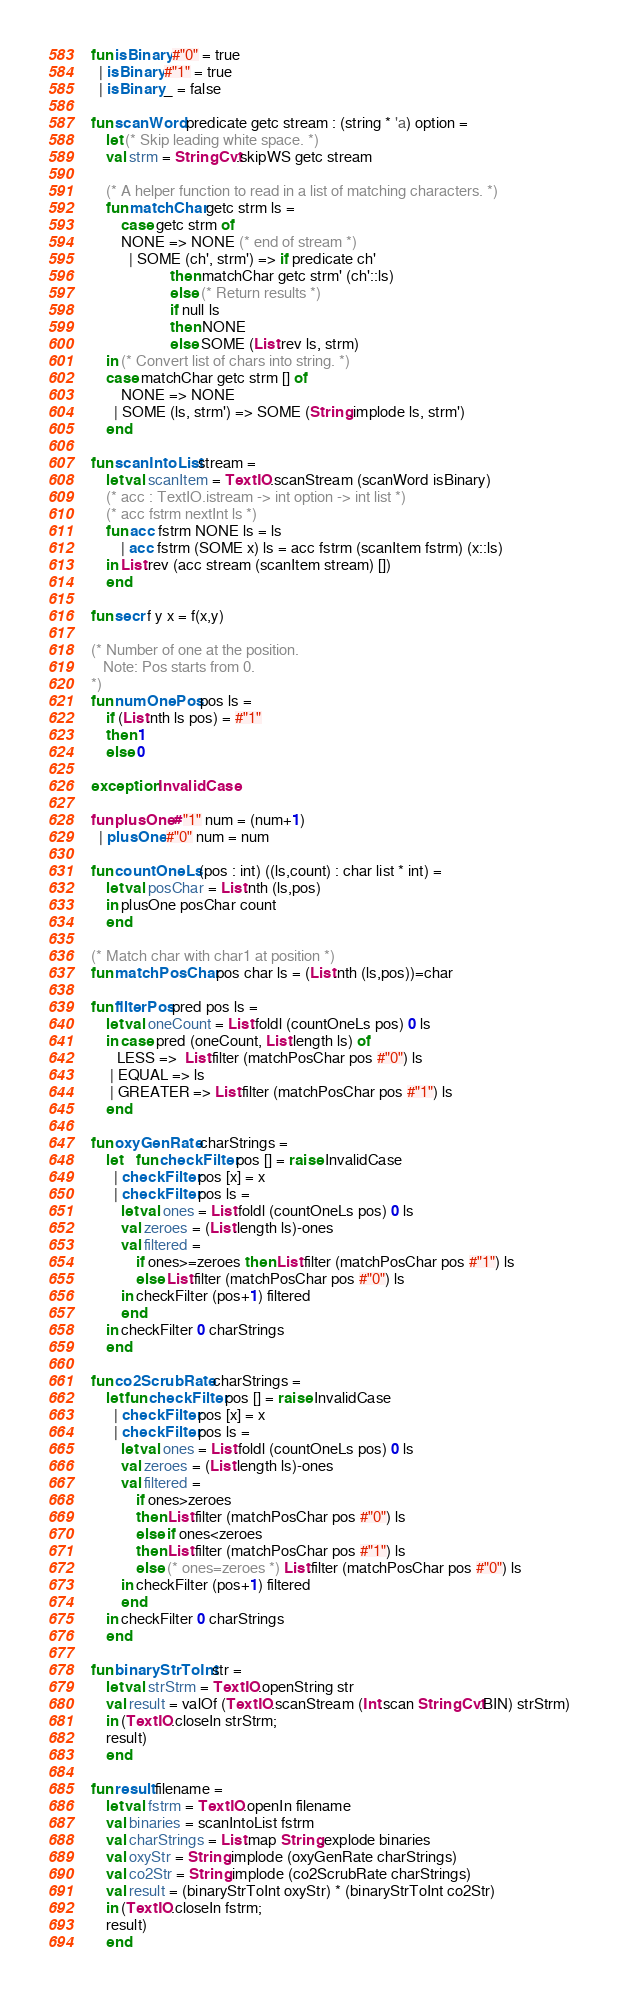<code> <loc_0><loc_0><loc_500><loc_500><_SML_>fun isBinary #"0" = true
  | isBinary #"1" = true
  | isBinary _ = false

fun scanWord predicate getc stream : (string * 'a) option =
    let (* Skip leading white space. *)
	val strm = StringCvt.skipWS getc stream

	(* A helper function to read in a list of matching characters. *)
	fun matchChar getc strm ls =
	    case getc strm of
		NONE => NONE (* end of stream *)
	      | SOME (ch', strm') => if predicate ch'
				     then matchChar getc strm' (ch'::ls)
				     else (* Return results *)
					 if null ls
					 then NONE
					 else SOME (List.rev ls, strm)
    in (* Convert list of chars into string. *)
	case matchChar getc strm [] of
	    NONE => NONE
	  | SOME (ls, strm') => SOME (String.implode ls, strm')
    end

fun scanIntoList stream =
    let val scanItem = TextIO.scanStream (scanWord isBinary)
	(* acc : TextIO.istream -> int option -> int list *)
	(* acc fstrm nextInt ls *)
	fun acc fstrm NONE ls = ls
	    | acc fstrm (SOME x) ls = acc fstrm (scanItem fstrm) (x::ls)
    in List.rev (acc stream (scanItem stream) [])
    end

fun secr f y x = f(x,y)

(* Number of one at the position.
   Note: Pos starts from 0.
*)
fun numOnePos pos ls =
    if (List.nth ls pos) = #"1"
    then 1
    else 0

exception InvalidCase

fun plusOne #"1" num = (num+1)
  | plusOne #"0" num = num

fun countOneLs (pos : int) ((ls,count) : char list * int) =
    let val posChar = List.nth (ls,pos)
    in plusOne posChar count
    end

(* Match char with char1 at position *)
fun matchPosChar pos char ls = (List.nth (ls,pos))=char

fun filterPos pred pos ls =
    let val oneCount = List.foldl (countOneLs pos) 0 ls
    in case pred (oneCount, List.length ls) of
	   LESS =>  List.filter (matchPosChar pos #"0") ls
	 | EQUAL => ls
	 | GREATER => List.filter (matchPosChar pos #"1") ls
    end

fun oxyGenRate charStrings =
    let	fun checkFilter pos [] = raise InvalidCase
	  | checkFilter pos [x] = x
	  | checkFilter pos ls =
	    let val ones = List.foldl (countOneLs pos) 0 ls
		val zeroes = (List.length ls)-ones
		val filtered =
		    if ones>=zeroes then List.filter (matchPosChar pos #"1") ls
		    else List.filter (matchPosChar pos #"0") ls
	    in checkFilter (pos+1) filtered
	    end
    in checkFilter 0 charStrings
    end

fun co2ScrubRate charStrings =
    let fun checkFilter pos [] = raise InvalidCase
	  | checkFilter pos [x] = x
	  | checkFilter pos ls =
	    let val ones = List.foldl (countOneLs pos) 0 ls
		val zeroes = (List.length ls)-ones
		val filtered =
		    if ones>zeroes
		    then List.filter (matchPosChar pos #"0") ls
		    else if ones<zeroes
		    then List.filter (matchPosChar pos #"1") ls
		    else (* ones=zeroes *) List.filter (matchPosChar pos #"0") ls
	    in checkFilter (pos+1) filtered
	    end
    in checkFilter 0 charStrings
    end

fun binaryStrToInt str =
    let val strStrm = TextIO.openString str
	val result = valOf (TextIO.scanStream (Int.scan StringCvt.BIN) strStrm)
    in (TextIO.closeIn strStrm;
	result)
    end

fun result filename =
    let val fstrm = TextIO.openIn filename
	val binaries = scanIntoList fstrm
	val charStrings = List.map String.explode binaries
	val oxyStr = String.implode (oxyGenRate charStrings)
	val co2Str = String.implode (co2ScrubRate charStrings)
	val result = (binaryStrToInt oxyStr) * (binaryStrToInt co2Str)
    in (TextIO.closeIn fstrm;
	result)
    end
</code> 